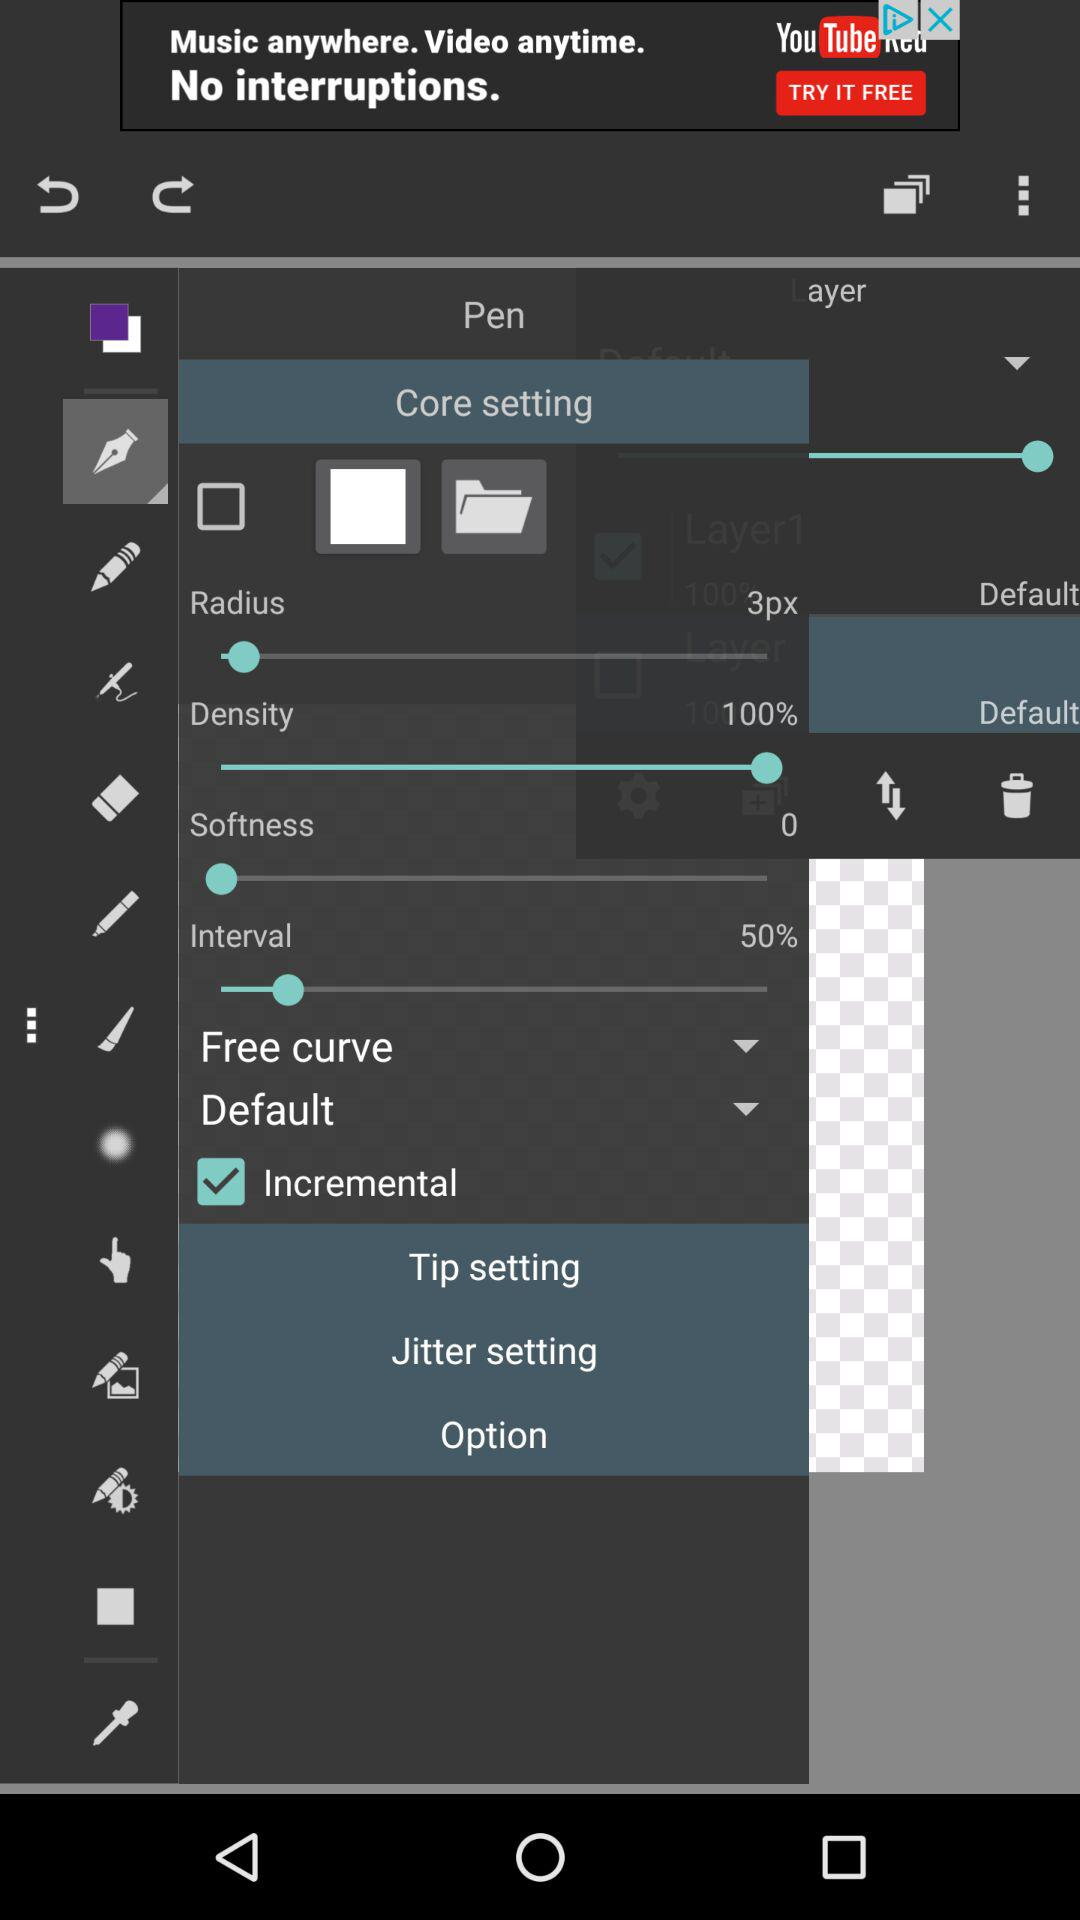Which is the selected option?
When the provided information is insufficient, respond with <no answer>. <no answer> 